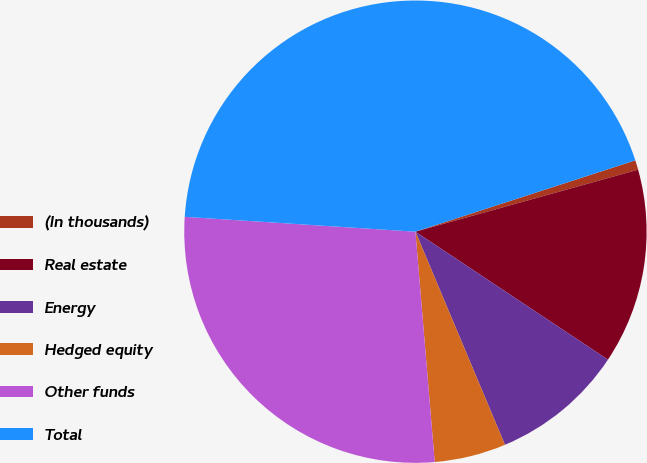Convert chart. <chart><loc_0><loc_0><loc_500><loc_500><pie_chart><fcel>(In thousands)<fcel>Real estate<fcel>Energy<fcel>Hedged equity<fcel>Other funds<fcel>Total<nl><fcel>0.67%<fcel>13.66%<fcel>9.33%<fcel>5.0%<fcel>27.35%<fcel>43.98%<nl></chart> 